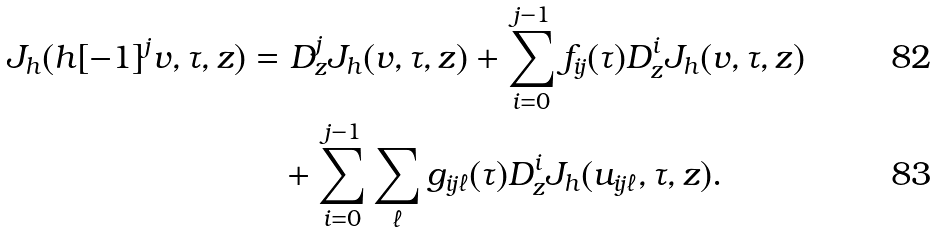<formula> <loc_0><loc_0><loc_500><loc_500>J _ { h } ( h [ - 1 ] ^ { j } v , \tau , z ) & = D _ { z } ^ { j } J _ { h } ( v , \tau , z ) + \sum _ { i = 0 } ^ { j - 1 } f _ { i j } ( \tau ) D _ { z } ^ { i } J _ { h } ( v , \tau , z ) \\ & \quad + \sum _ { i = 0 } ^ { j - 1 } \sum _ { \ell } g _ { i j \ell } ( \tau ) D _ { z } ^ { i } J _ { h } ( u _ { i j \ell } , \tau , z ) .</formula> 